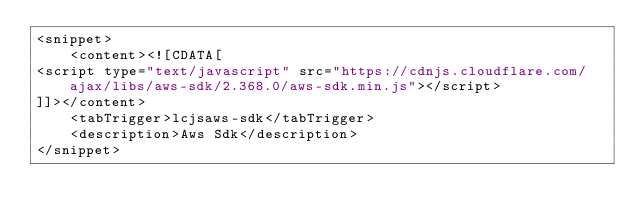<code> <loc_0><loc_0><loc_500><loc_500><_XML_><snippet>
    <content><![CDATA[
<script type="text/javascript" src="https://cdnjs.cloudflare.com/ajax/libs/aws-sdk/2.368.0/aws-sdk.min.js"></script>
]]></content>
    <tabTrigger>lcjsaws-sdk</tabTrigger>
    <description>Aws Sdk</description>
</snippet>
</code> 